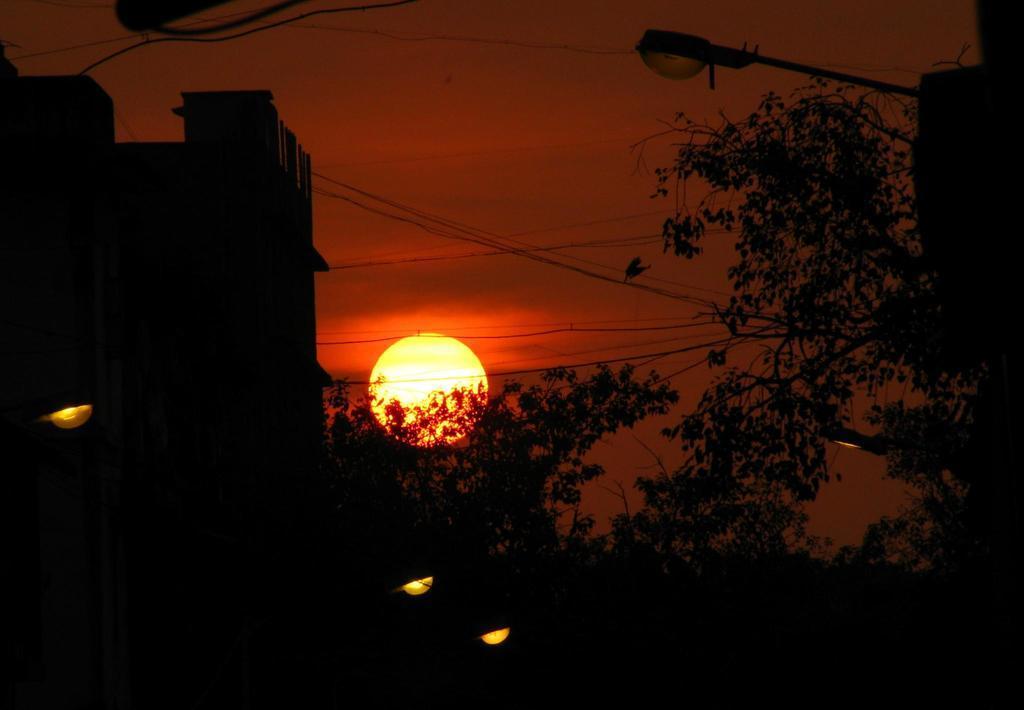Please provide a concise description of this image. In this image I can see trees. There is a light pole on the right. There is a building on the left. There are wires and there is sun in the sky. 